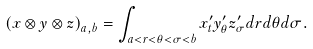<formula> <loc_0><loc_0><loc_500><loc_500>\left ( x \otimes y \otimes z \right ) _ { a , b } = \int _ { a < r < \theta < \sigma < b } x _ { t } ^ { \prime } y _ { \theta } ^ { \prime } z _ { \sigma } ^ { \prime } d r d \theta d \sigma .</formula> 